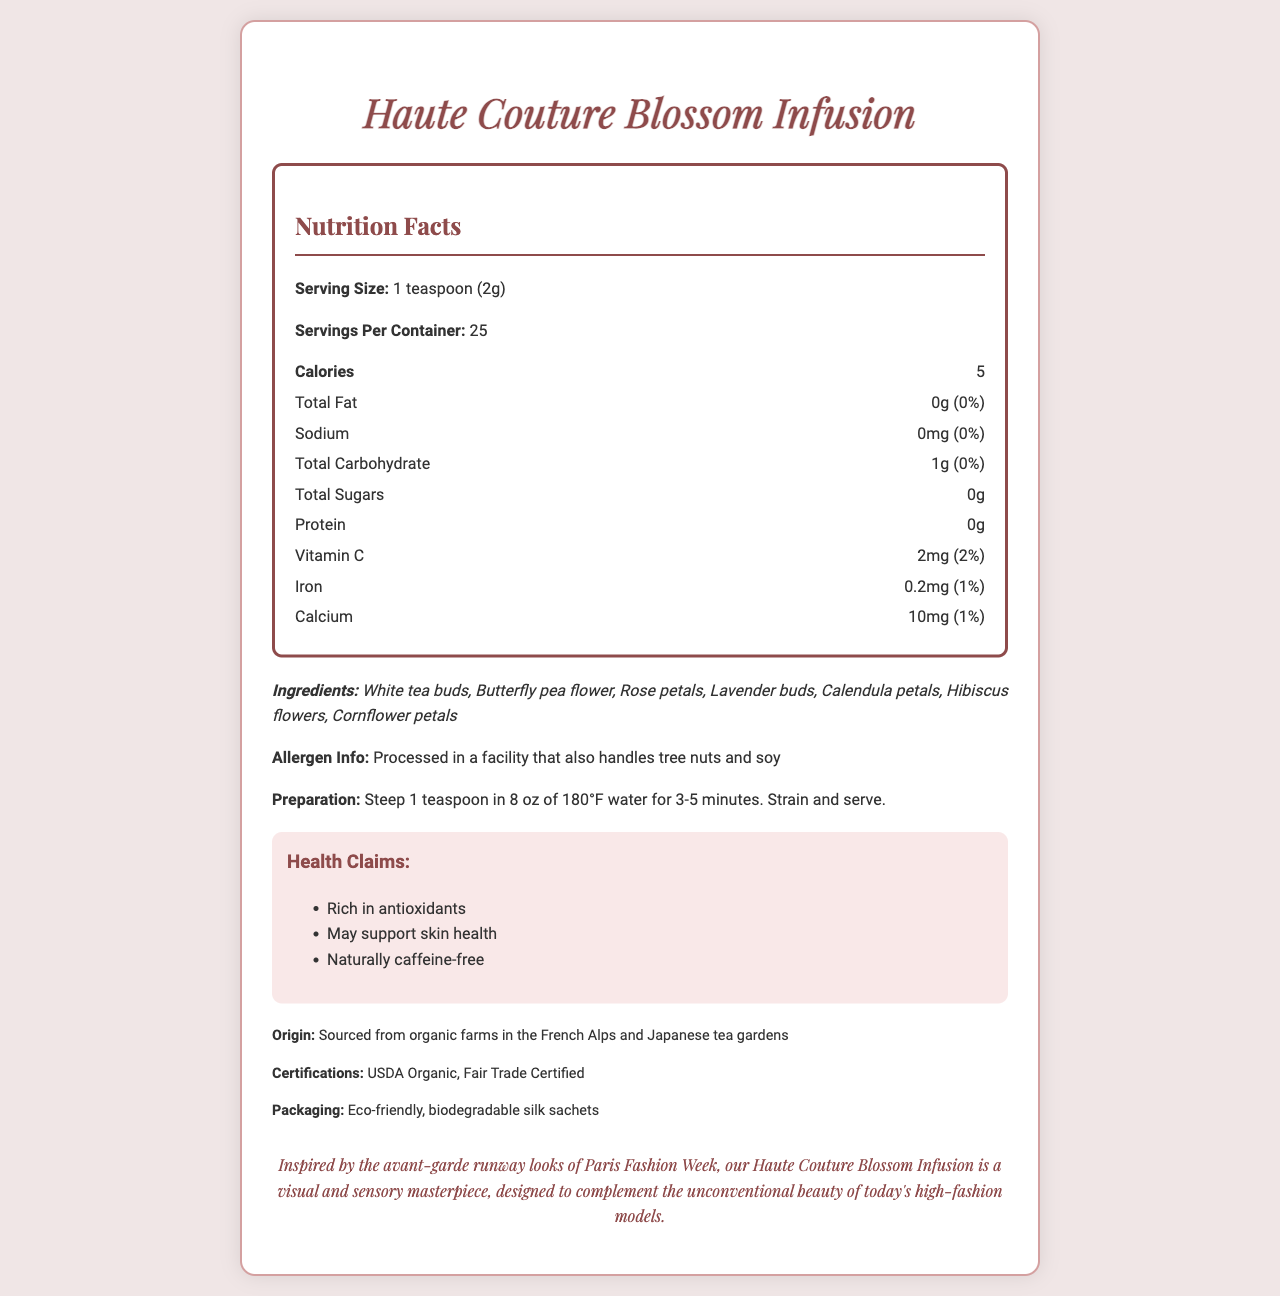What is the serving size? The serving size is mentioned at the beginning of the Nutrition Facts section.
Answer: 1 teaspoon (2g) How many calories are in one serving? The number of calories per serving is listed under the Nutrition Facts.
Answer: 5 How many servings are in a container? The number of servings per container is specified in the Nutrition Facts section.
Answer: 25 What allergens should consumers be aware of? The allergen information is explicitly mentioned in the document.
Answer: Processed in a facility that also handles tree nuts and soy What is the preparation method for this tea? The preparation instructions section details how to prepare the tea.
Answer: Steep 1 teaspoon in 8 oz of 180°F water for 3-5 minutes. Strain and serve. Which ingredient is common among this tea blend? A. Jasmine B. Rose petals C. Lemongrass D. Mint Only Rose petals are listed in the ingredients.
Answer: B. Rose petals What is the percentage daily value of calcium per serving? A. 0% B. 1% C. 2% D. 5% The percentage daily value of calcium is 1%, as indicated in the Nutrition Facts.
Answer: B. 1% Is this tea blend naturally caffeine-free? One of the health claims listed mentions that the tea is naturally caffeine-free.
Answer: Yes Does the product have any certifications? The additional information section mentions that the product is USDA Organic and Fair Trade Certified.
Answer: Yes Summarize the main idea of this document. The document is primarily focused on providing detailed nutritional information and background about the "Haute Couture Blossom Infusion" tea blend, highlighting its unique ingredients and health benefits.
Answer: The document contains the nutritional facts, ingredients, allergen information, preparation instructions, health claims, and additional information about the "Haute Couture Blossom Infusion" tea blend. It is a high-fashion tea sourced from organic farms, packaged in eco-friendly sachets, and contains various edible flower petals. What is the place of origin for this tea blend? The origin information is provided in the additional info section.
Answer: Sourced from organic farms in the French Alps and Japanese tea gardens How much vitamin C does one serving provide? The amount of vitamin C per serving is listed in the Nutrition Facts.
Answer: 2mg What is the protein content per serving? The protein content per serving is indicated in the Nutrition Facts.
Answer: 0g Can we determine the exact price of the tea blend from the document? The document does not provide any pricing details about the tea blend.
Answer: Not enough information 